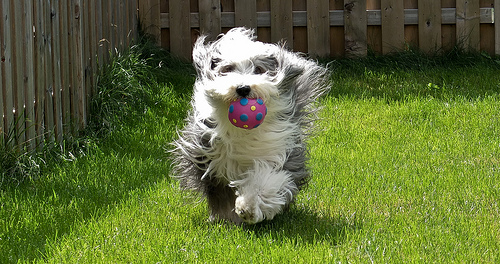<image>
Is there a ball on the ground? No. The ball is not positioned on the ground. They may be near each other, but the ball is not supported by or resting on top of the ground. 